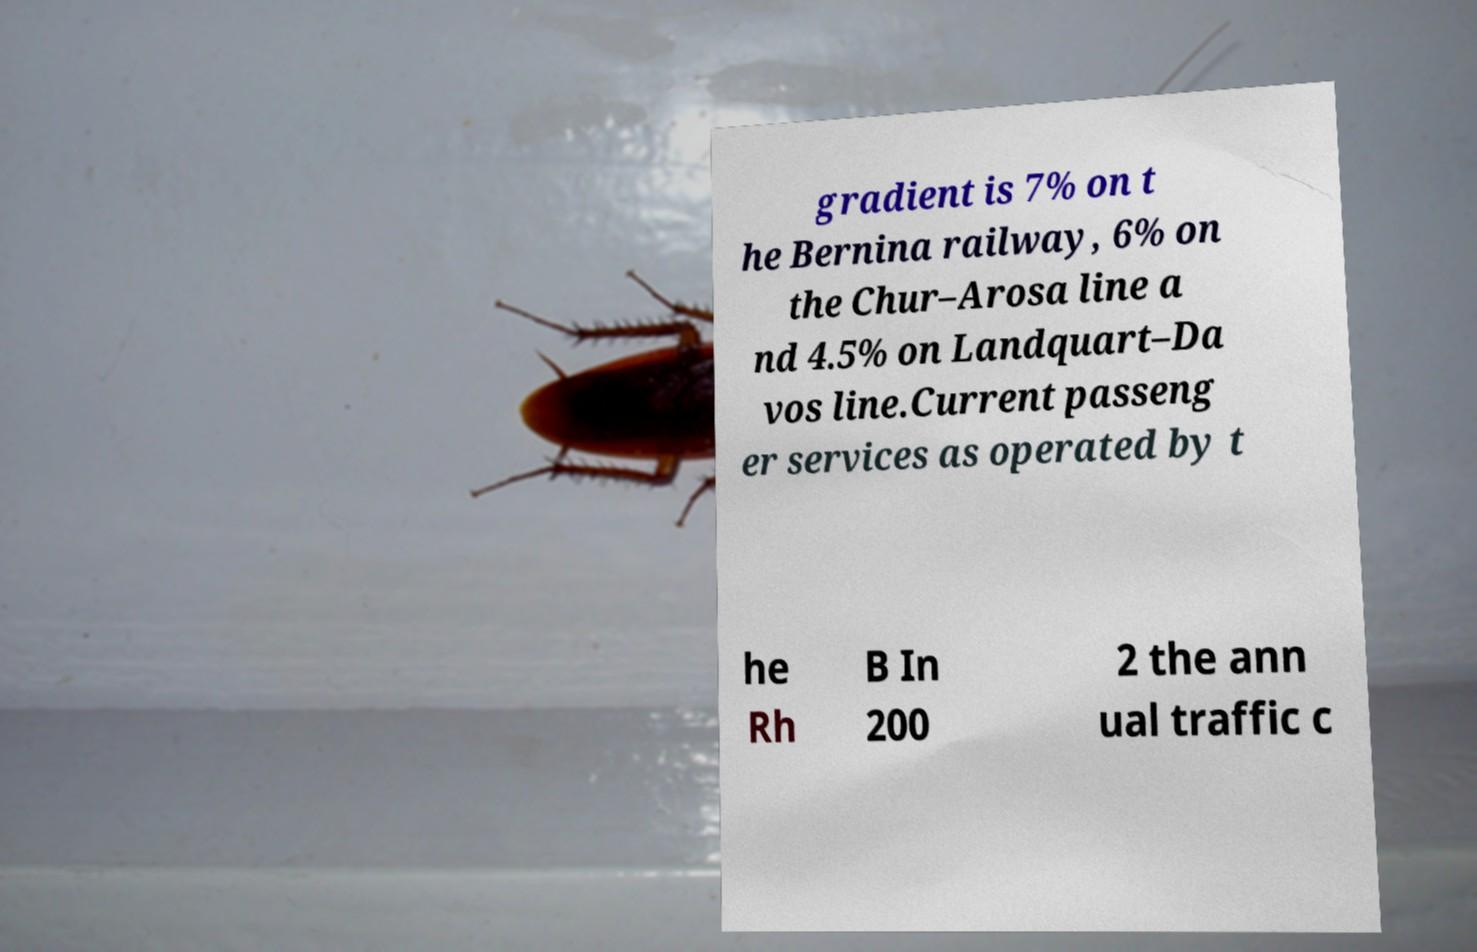Can you read and provide the text displayed in the image?This photo seems to have some interesting text. Can you extract and type it out for me? gradient is 7% on t he Bernina railway, 6% on the Chur–Arosa line a nd 4.5% on Landquart–Da vos line.Current passeng er services as operated by t he Rh B In 200 2 the ann ual traffic c 